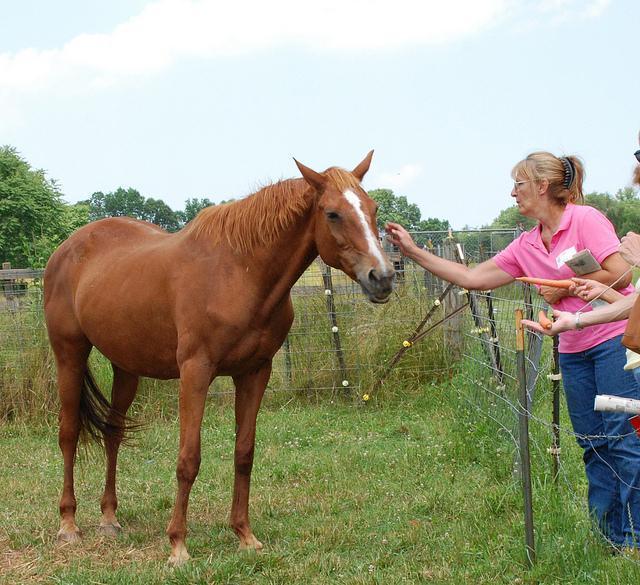How many horses in the fence?
Give a very brief answer. 1. How many horses?
Give a very brief answer. 1. How many horses are in this photo?
Give a very brief answer. 1. How many horses are in the photo?
Give a very brief answer. 1. How many people can be seen?
Give a very brief answer. 2. How many big elephants are there?
Give a very brief answer. 0. 